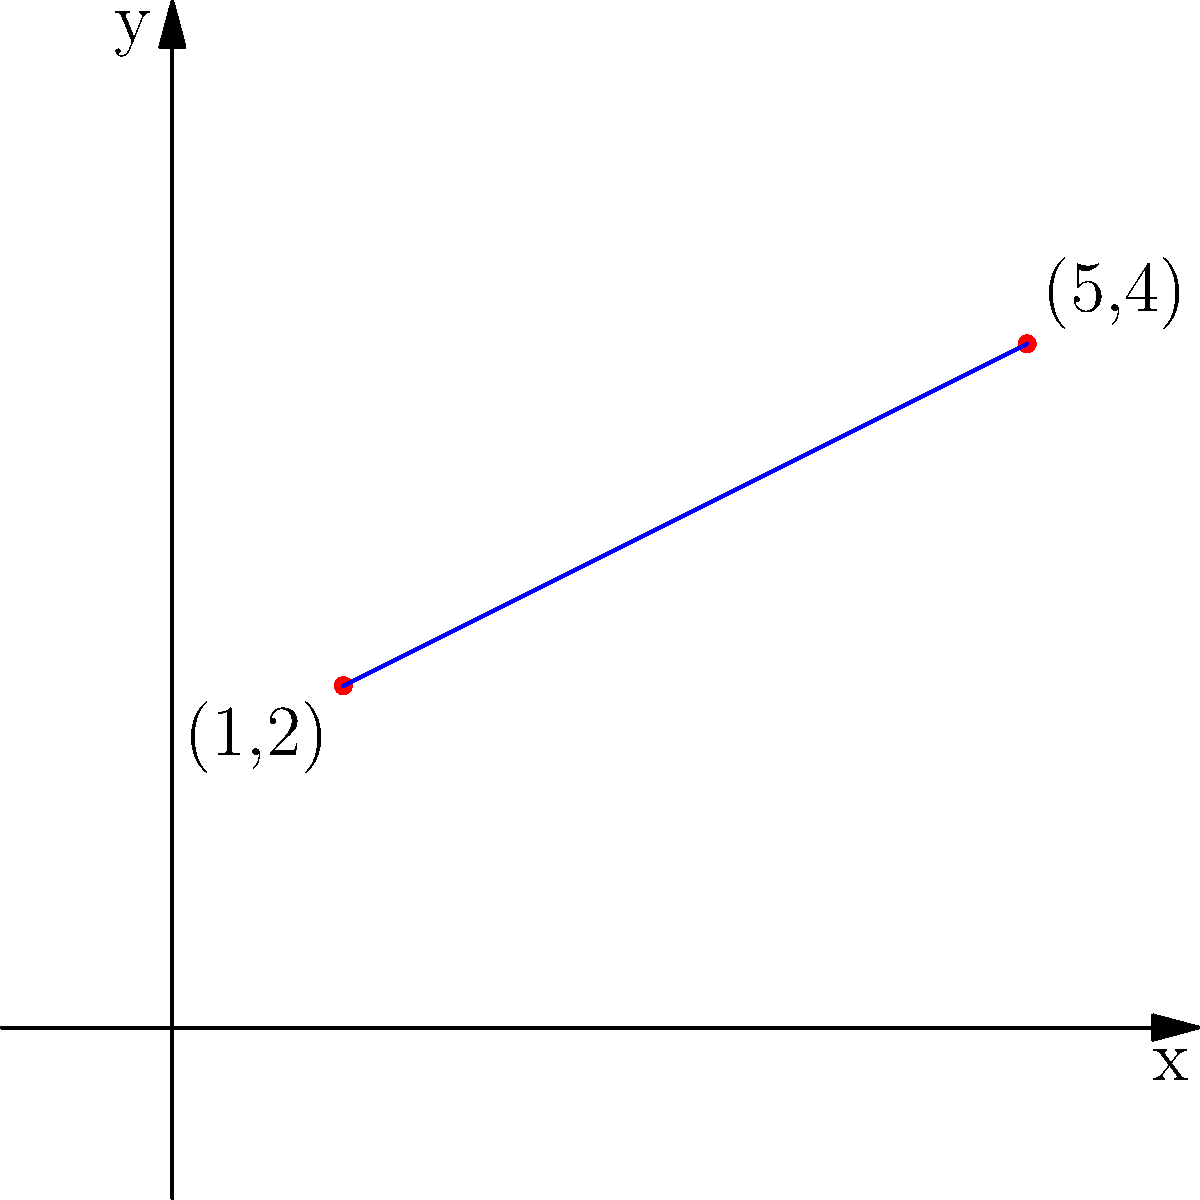In your immunology research, you're plotting antibody concentrations over time. Two key data points are represented by the coordinates (1,2) and (5,4), where the x-axis represents days and the y-axis represents antibody concentration. Find the equation of the line passing through these two points, which could help predict antibody levels on future days. Express your answer in slope-intercept form: $y = mx + b$. Let's approach this step-by-step with a positive mindset, just as we would tackle a complex immunological problem:

1) First, we need to calculate the slope (m) of the line. The slope formula is:
   
   $m = \frac{y_2 - y_1}{x_2 - x_1}$

2) We have two points: $(x_1, y_1) = (1, 2)$ and $(x_2, y_2) = (5, 4)$

3) Let's plug these into our slope formula:
   
   $m = \frac{4 - 2}{5 - 1} = \frac{2}{4} = \frac{1}{2}$

4) Now that we have the slope, we can use the point-slope form of a line:
   
   $y - y_1 = m(x - x_1)$

5) Let's use the point (1, 2) and our calculated slope:
   
   $y - 2 = \frac{1}{2}(x - 1)$

6) Distribute the $\frac{1}{2}$:
   
   $y - 2 = \frac{1}{2}x - \frac{1}{2}$

7) Add 2 to both sides to isolate y:
   
   $y = \frac{1}{2}x - \frac{1}{2} + 2$

8) Simplify:
   
   $y = \frac{1}{2}x + \frac{3}{2}$

This equation represents the trend in antibody concentration over time, which could be valuable for predicting future immune responses!
Answer: $y = \frac{1}{2}x + \frac{3}{2}$ 